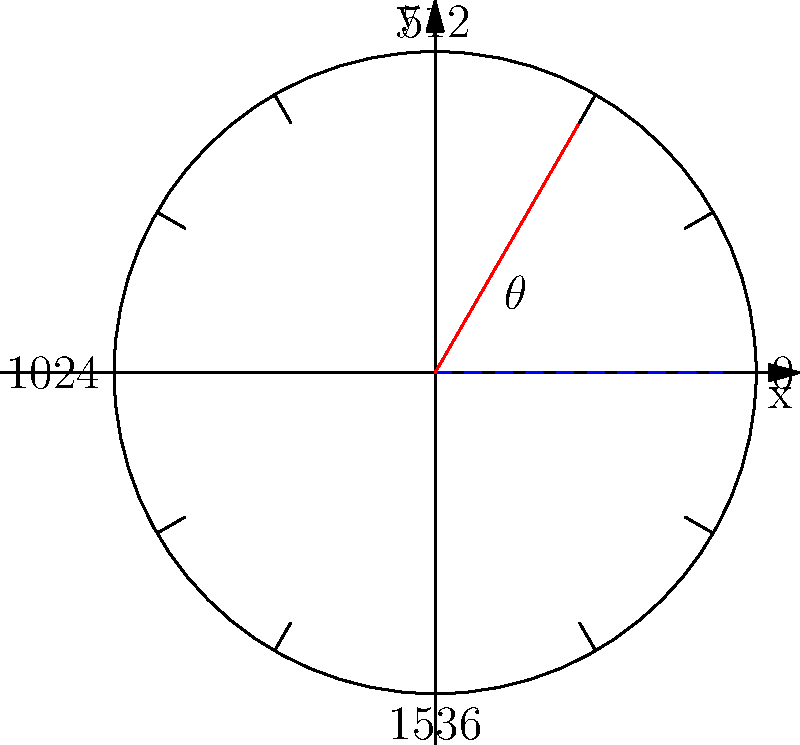An optical encoder with 2048 counts per revolution is used to measure the angle of rotation for a robotic arm joint. If the encoder reading shows a count of 341, what is the angle of rotation in degrees? To solve this problem, we need to follow these steps:

1) First, we need to understand the relationship between encoder counts and a full rotation:
   - One full rotation (360°) corresponds to 2048 counts

2) We can set up a proportion to relate counts to degrees:
   $\frac{2048 \text{ counts}}{360°} = \frac{341 \text{ counts}}{\theta°}$

3) Cross multiply:
   $2048\theta = 360 \times 341$

4) Solve for $\theta$:
   $\theta = \frac{360 \times 341}{2048}$

5) Calculate:
   $\theta = \frac{122760}{2048} = 59.94°$

6) Round to two decimal places:
   $\theta \approx 59.94°$

Therefore, the angle of rotation is approximately 59.94°.
Answer: 59.94° 